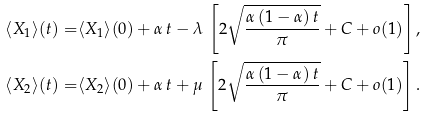Convert formula to latex. <formula><loc_0><loc_0><loc_500><loc_500>\langle X _ { 1 } \rangle ( t ) = & \langle X _ { 1 } \rangle ( 0 ) + \alpha \, t - \lambda \, \left [ 2 \sqrt { \frac { \alpha \, ( 1 - \alpha ) \, t } { \pi } } + C + o ( 1 ) \right ] , \\ \langle X _ { 2 } \rangle ( t ) = & \langle X _ { 2 } \rangle ( 0 ) + \alpha \, t + \mu \, \left [ 2 \sqrt { \frac { \alpha \, ( 1 - \alpha ) \, t } { \pi } } + C + o ( 1 ) \right ] .</formula> 